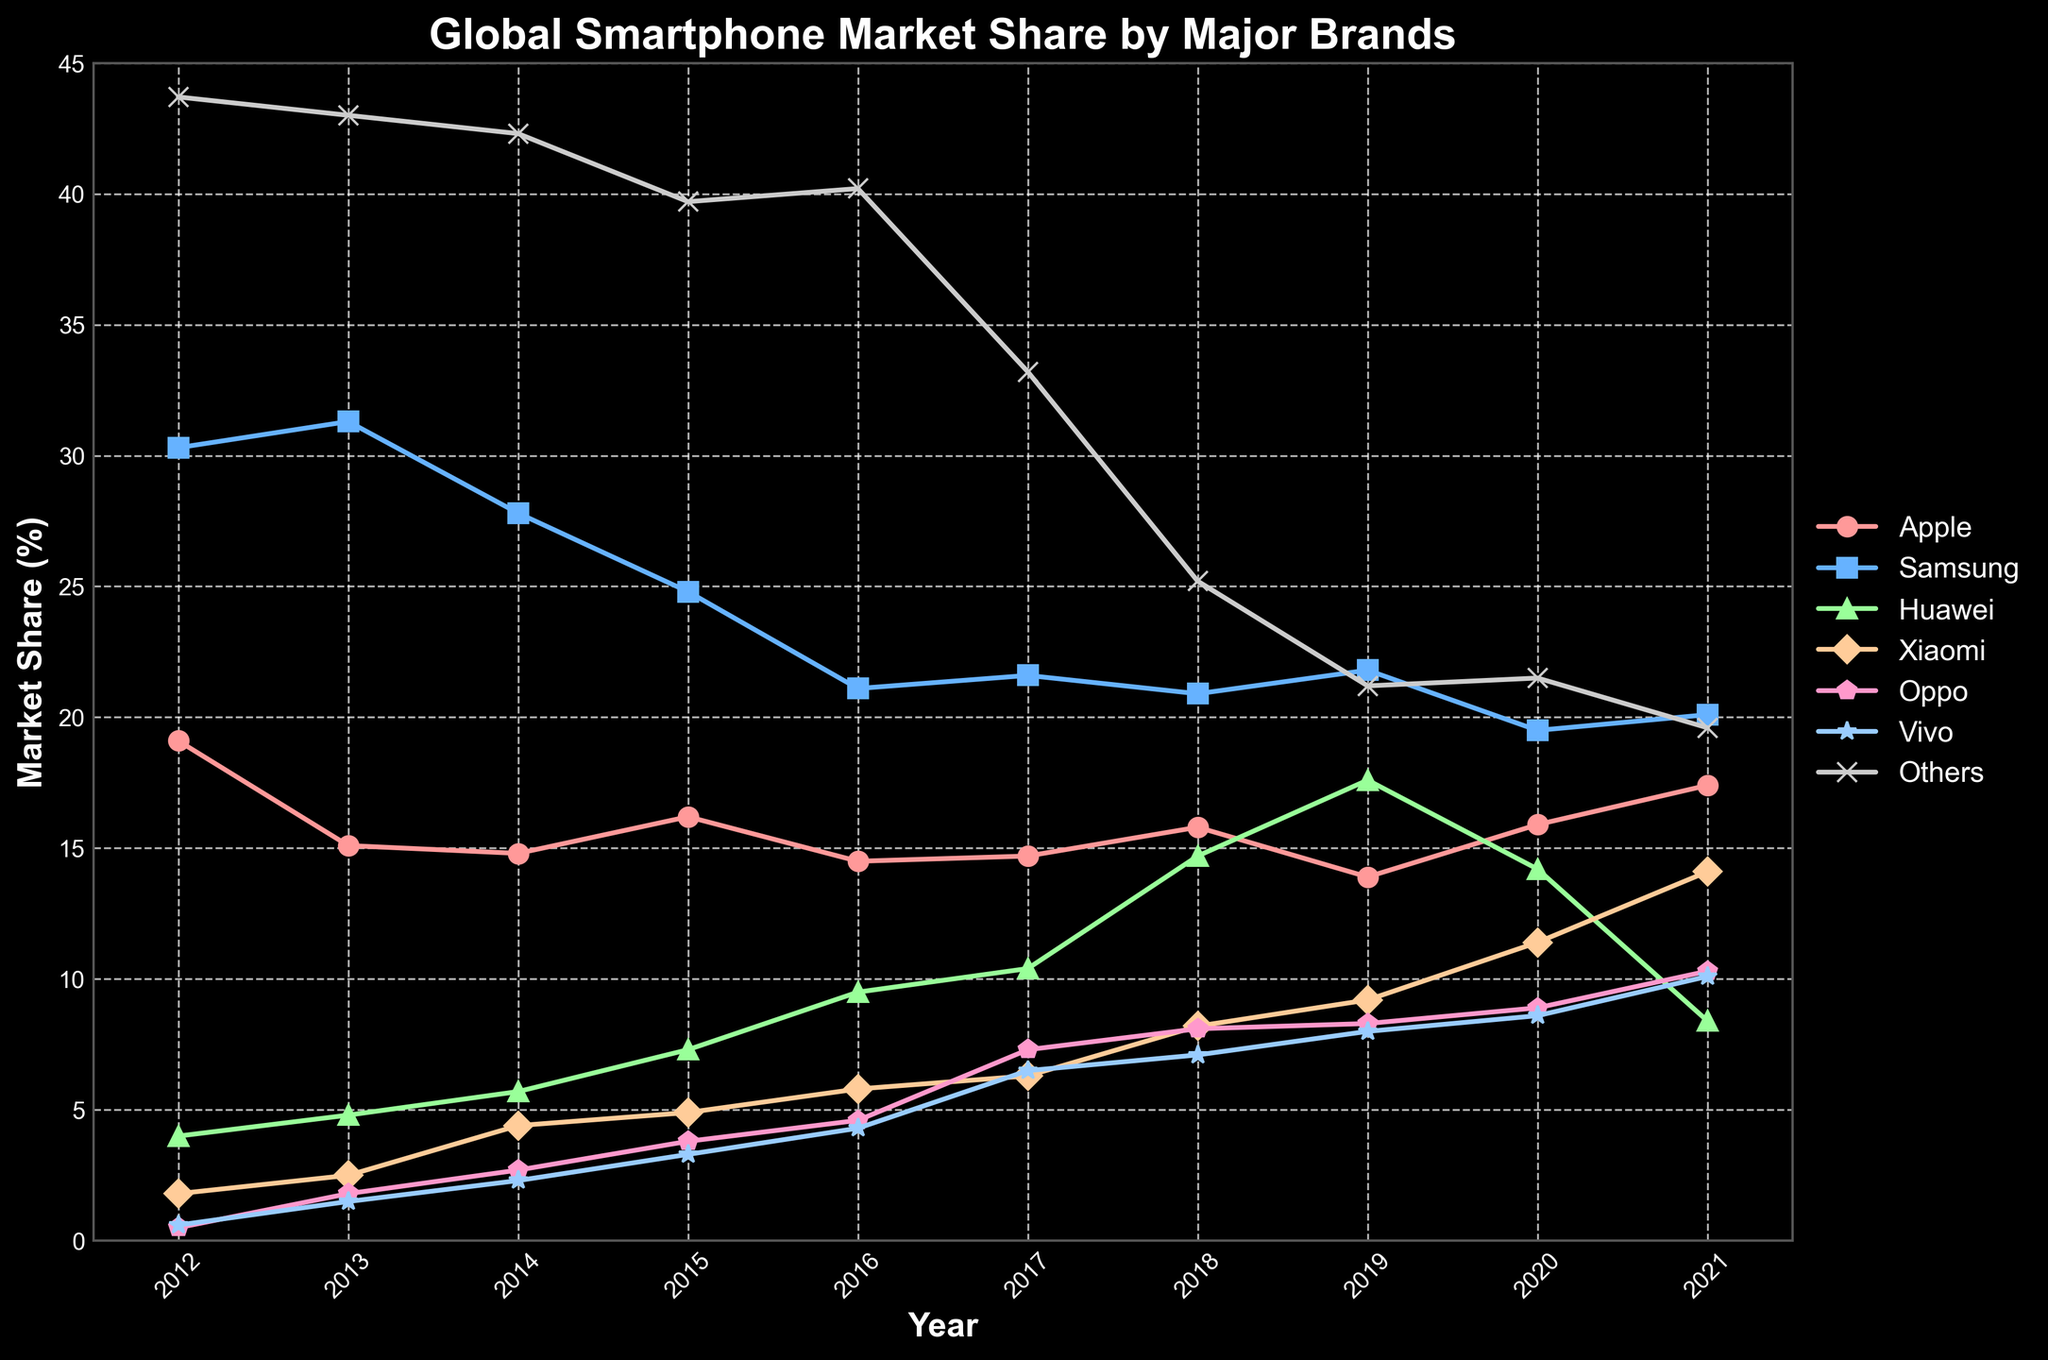Which brand had the highest market share in 2012? By looking at the data points for the year 2012, we compare the market share values of all brands. Samsung has the highest value at 30.3%.
Answer: Samsung How did the market share of Huawei change from 2016 to 2020? To determine this, we look at Huawei's market shares for 2016 and 2020. In 2016, it was 9.5%, and in 2020, it was 14.2%. The change is 14.2% - 9.5% = 4.7%.
Answer: Increased by 4.7% What was the combined market share of Oppo and Vivo in 2018? First, we find Oppo's market share in 2018, which is 8.1%, and Vivo's market share in 2018, which is 7.1%. Adding these gives 8.1% + 7.1% = 15.2%.
Answer: 15.2% Which brand had the most significant increase in market share from 2012 to 2021? We find the difference in market share for each brand between 2012 and 2021, then compare these differences. Huawei had the most significant increase from 4.0% in 2012 to 8.4% in 2021, an increase of 4.4%.
Answer: Huawei Was Apple's market share higher in 2015 or 2020? Looking at Apple's market share, we find 16.2% in 2015 and 15.9% in 2020. The market share was higher in 2015.
Answer: 2015 What is the trend in the "Others" category from 2012 to 2021? Observing the plotted line for "Others," we notice a general decreasing trend from 43.7% in 2012 to 19.6% in 2021.
Answer: Decreasing Compare the market shares of Xiaomi and Samsung in 2021. By looking at the values for 2021, Xiaomi has a market share of 14.1% while Samsung has 20.1%. Samsung has a higher market share in 2021.
Answer: Samsung How did Vivo's market share evolve between 2017 and 2021? By comparing Vivo's market share values, in 2017, it was 6.5%, and in 2021, it was 10.1%. The market share increased by 3.6%.
Answer: Increased by 3.6% Which year did Apple have the lowest market share, and what was it? By reviewing the data, Apple's lowest market share was 13.9% in 2019.
Answer: 2019, 13.9% What was the difference in market share between Apple and Huawei in 2021? Apple had a market share of 17.4% in 2021, while Huawei's was 8.4%. The difference is 17.4% - 8.4% = 9%.
Answer: 9% 